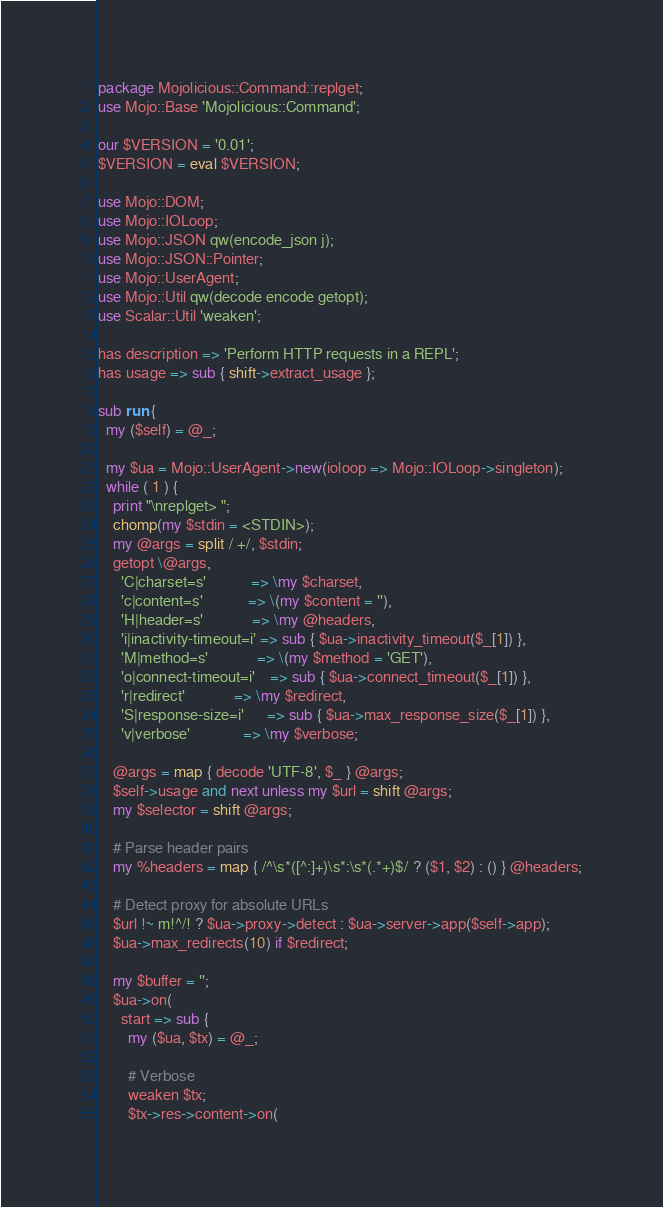<code> <loc_0><loc_0><loc_500><loc_500><_Perl_>package Mojolicious::Command::replget;
use Mojo::Base 'Mojolicious::Command';

our $VERSION = '0.01';
$VERSION = eval $VERSION;

use Mojo::DOM;
use Mojo::IOLoop;
use Mojo::JSON qw(encode_json j);
use Mojo::JSON::Pointer;
use Mojo::UserAgent;
use Mojo::Util qw(decode encode getopt);
use Scalar::Util 'weaken';

has description => 'Perform HTTP requests in a REPL';
has usage => sub { shift->extract_usage };

sub run {
  my ($self) = @_;

  my $ua = Mojo::UserAgent->new(ioloop => Mojo::IOLoop->singleton);
  while ( 1 ) {
    print "\nreplget> ";
    chomp(my $stdin = <STDIN>);
    my @args = split / +/, $stdin;
    getopt \@args,
      'C|charset=s'            => \my $charset,
      'c|content=s'            => \(my $content = ''),
      'H|header=s'             => \my @headers,
      'i|inactivity-timeout=i' => sub { $ua->inactivity_timeout($_[1]) },
      'M|method=s'             => \(my $method = 'GET'),
      'o|connect-timeout=i'    => sub { $ua->connect_timeout($_[1]) },
      'r|redirect'             => \my $redirect,
      'S|response-size=i'      => sub { $ua->max_response_size($_[1]) },
      'v|verbose'              => \my $verbose;

    @args = map { decode 'UTF-8', $_ } @args;
    $self->usage and next unless my $url = shift @args;
    my $selector = shift @args;

    # Parse header pairs
    my %headers = map { /^\s*([^:]+)\s*:\s*(.*+)$/ ? ($1, $2) : () } @headers;

    # Detect proxy for absolute URLs
    $url !~ m!^/! ? $ua->proxy->detect : $ua->server->app($self->app);
    $ua->max_redirects(10) if $redirect;

    my $buffer = '';
    $ua->on(
      start => sub {
        my ($ua, $tx) = @_;

        # Verbose
        weaken $tx;
        $tx->res->content->on(</code> 